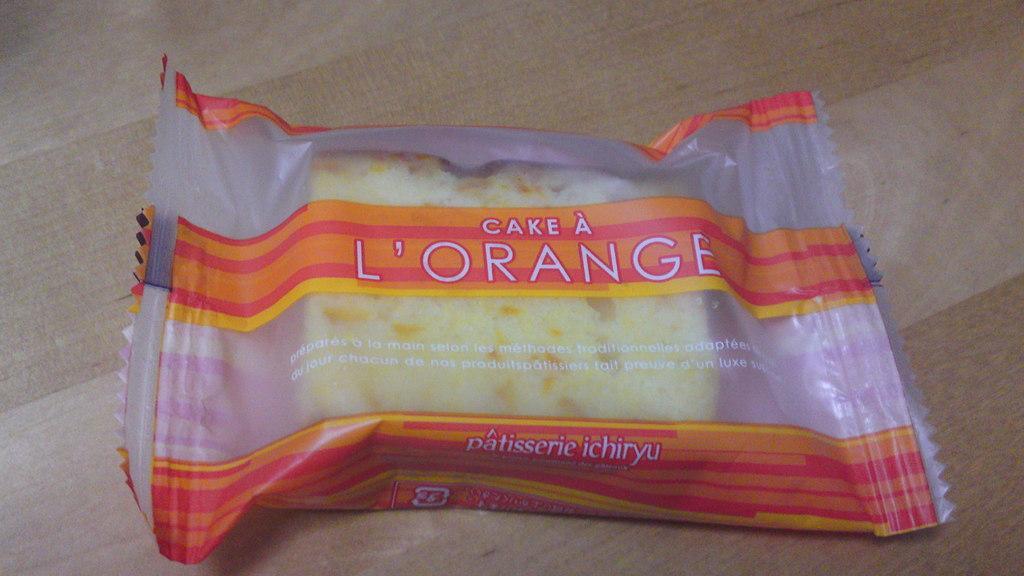Describe this image in one or two sentences. In this image I can see the cake packed with the plastic cover. The cake is in cream color. It is on the brown color surface. 